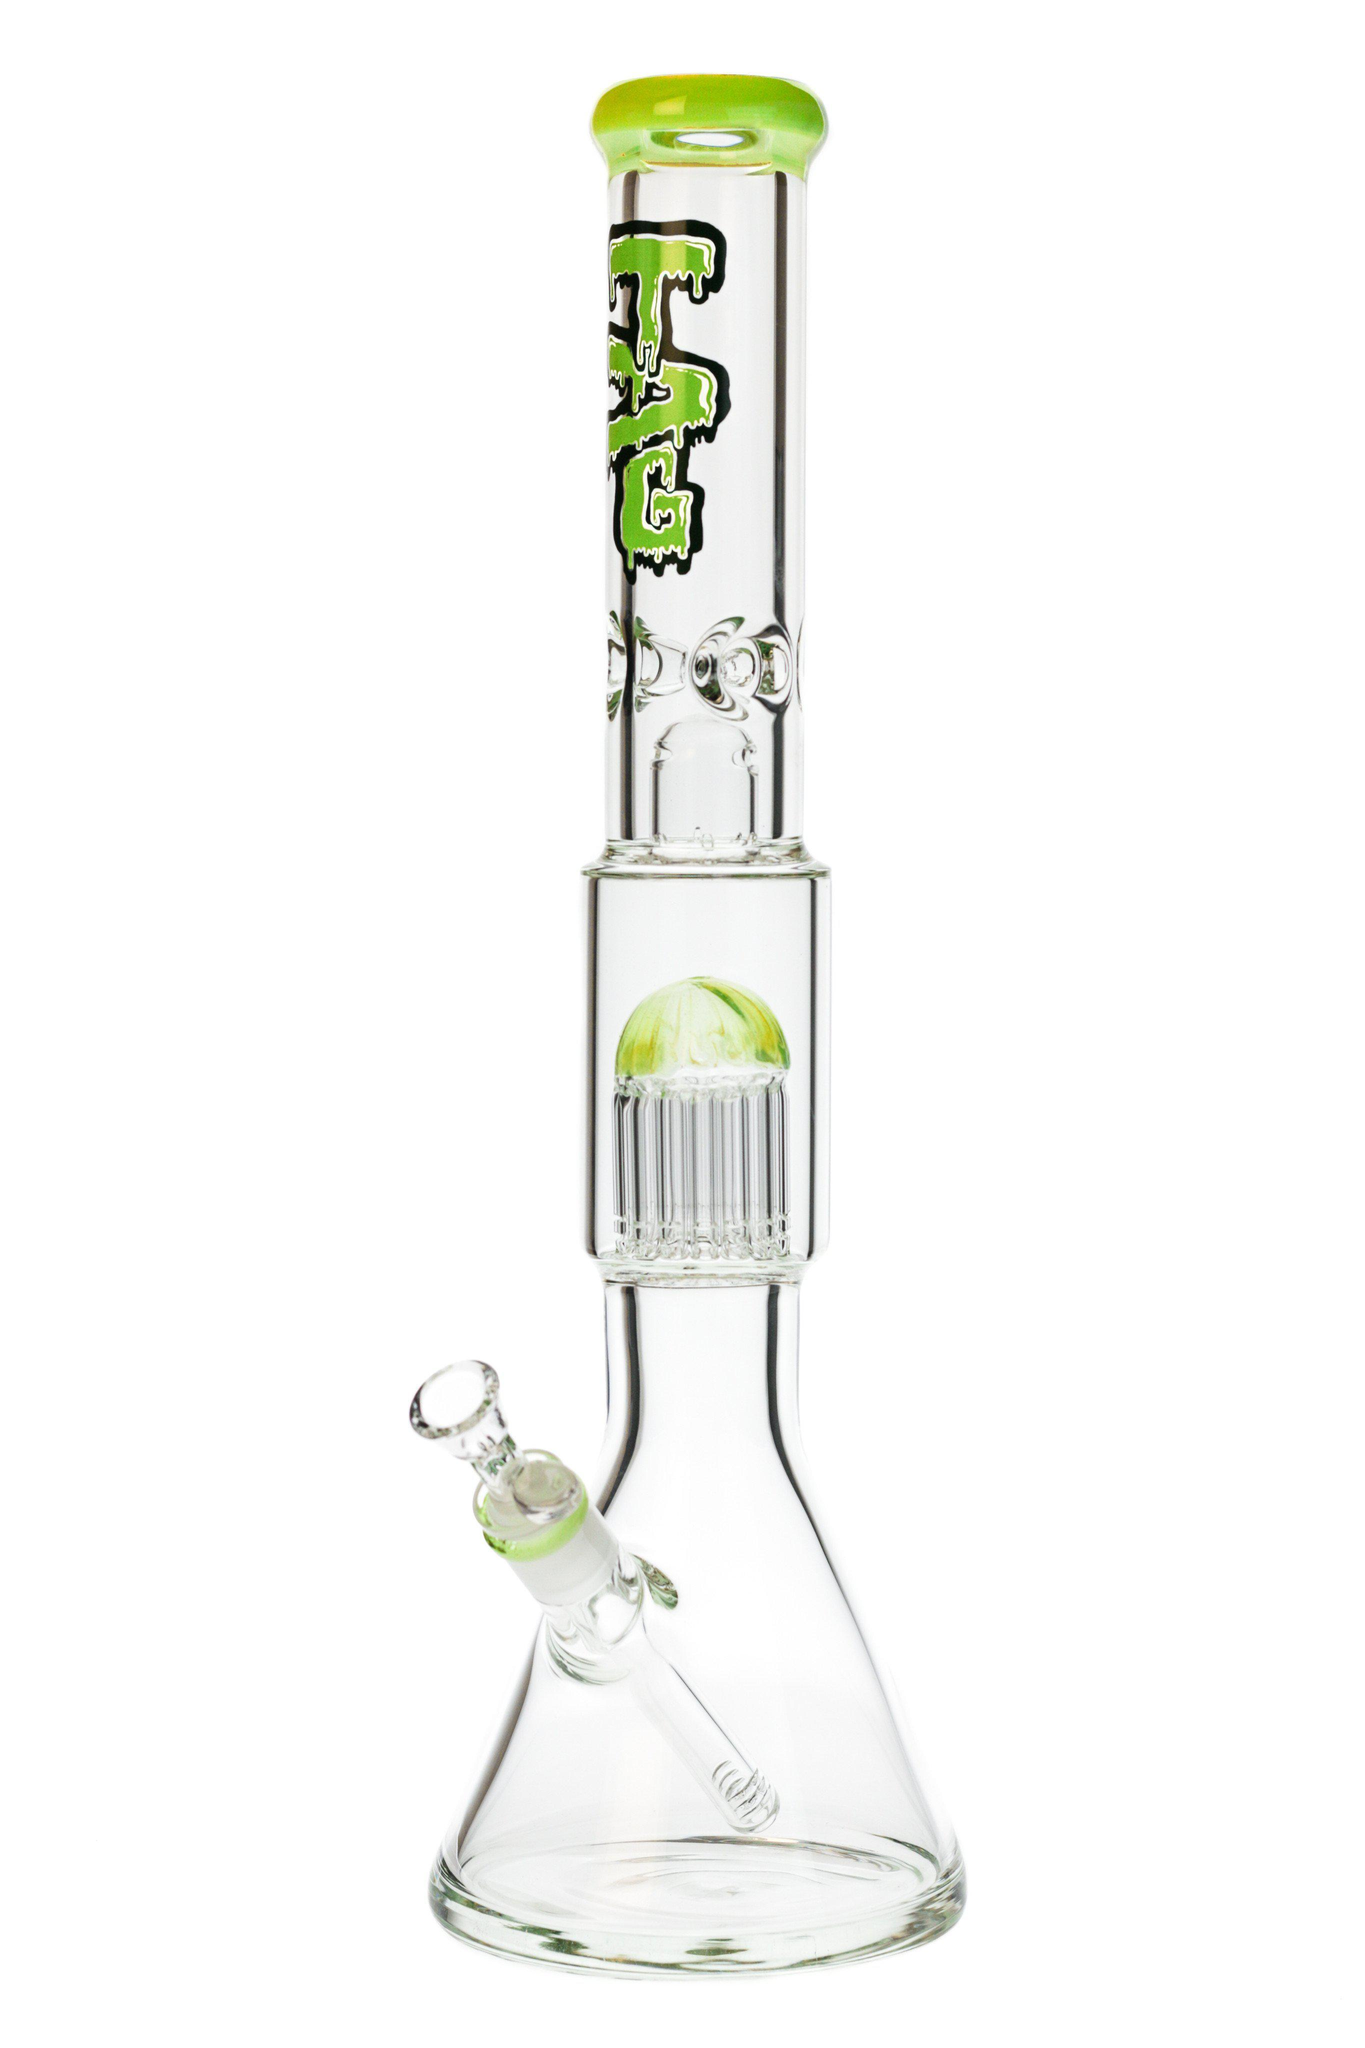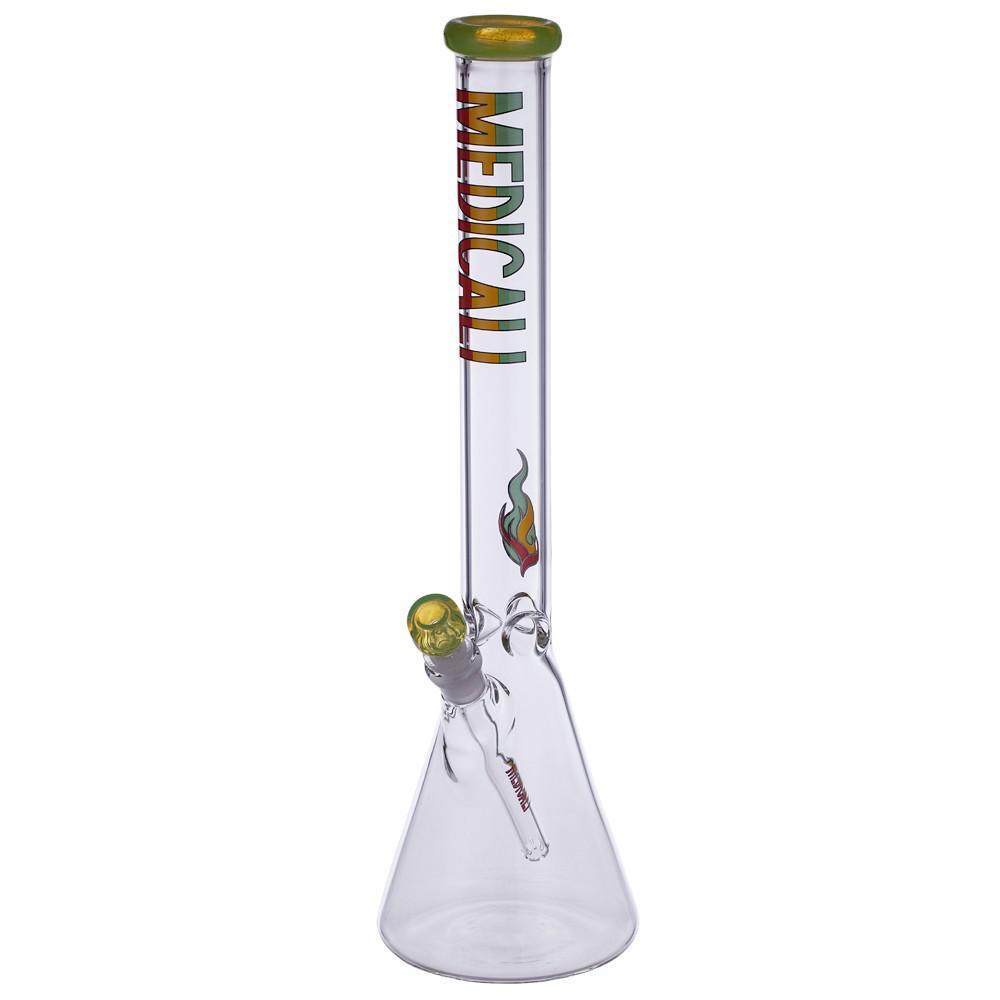The first image is the image on the left, the second image is the image on the right. Assess this claim about the two images: "The bowls of both bongs face the same direction.". Correct or not? Answer yes or no. Yes. The first image is the image on the left, the second image is the image on the right. For the images shown, is this caption "There are a total of two beaker bongs with the mouth pieces facing forward and left." true? Answer yes or no. Yes. 